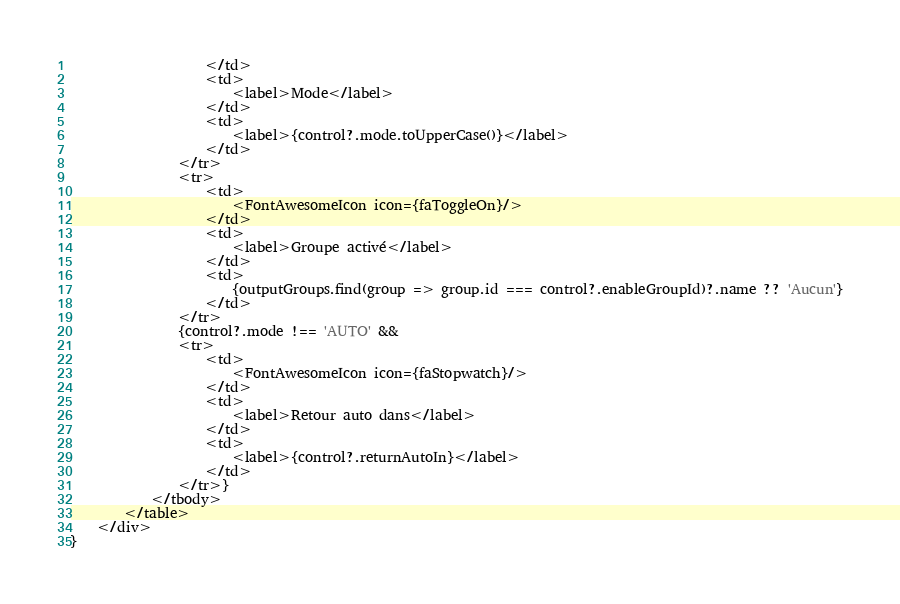Convert code to text. <code><loc_0><loc_0><loc_500><loc_500><_TypeScript_>                    </td>
                    <td>
                        <label>Mode</label>
                    </td>
                    <td>
                        <label>{control?.mode.toUpperCase()}</label>
                    </td>
                </tr>
                <tr>
                    <td>
                        <FontAwesomeIcon icon={faToggleOn}/>
                    </td>
                    <td>
                        <label>Groupe activé</label>
                    </td>
                    <td>
                        {outputGroups.find(group => group.id === control?.enableGroupId)?.name ?? 'Aucun'}
                    </td>
                </tr>
                {control?.mode !== 'AUTO' &&
                <tr>
                    <td>
                        <FontAwesomeIcon icon={faStopwatch}/>
                    </td>
                    <td>
                        <label>Retour auto dans</label>
                    </td>
                    <td>
                        <label>{control?.returnAutoIn}</label>
                    </td>
                </tr>}
            </tbody>
        </table>
    </div>
}
</code> 